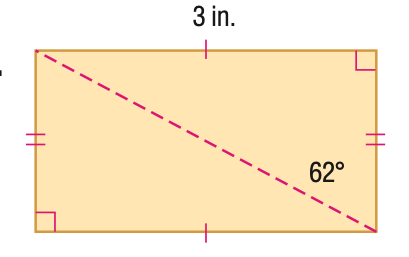Answer the mathemtical geometry problem and directly provide the correct option letter.
Question: Find the perimeter of the figure. Round to the nearest hundredth, if necessary.
Choices: A: 9.2 B: 12.8 C: 12.8 D: 17.3 A 